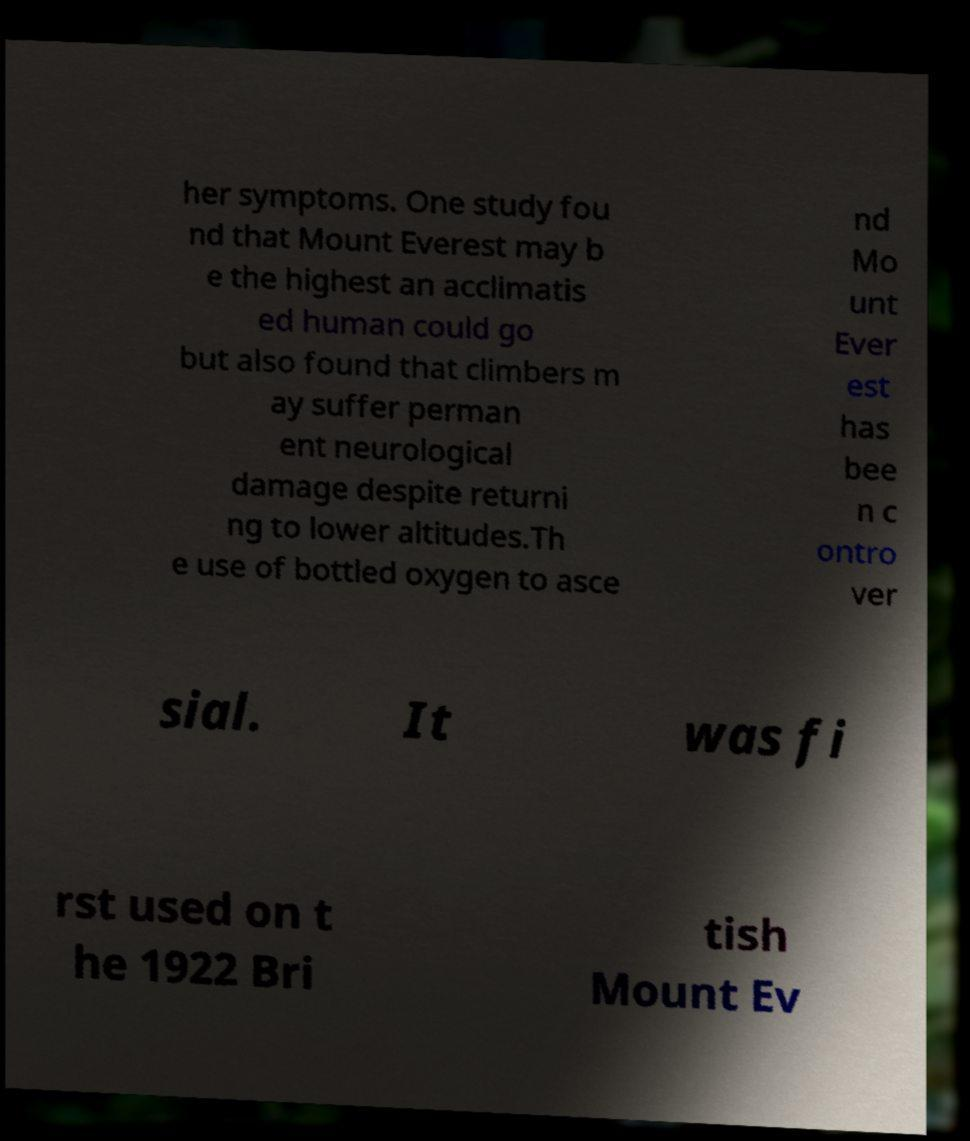Could you assist in decoding the text presented in this image and type it out clearly? her symptoms. One study fou nd that Mount Everest may b e the highest an acclimatis ed human could go but also found that climbers m ay suffer perman ent neurological damage despite returni ng to lower altitudes.Th e use of bottled oxygen to asce nd Mo unt Ever est has bee n c ontro ver sial. It was fi rst used on t he 1922 Bri tish Mount Ev 